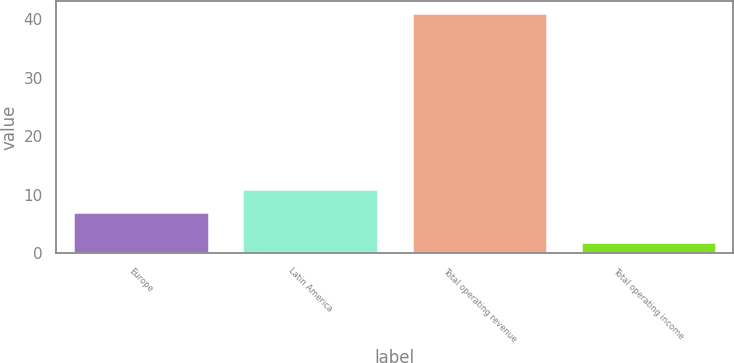<chart> <loc_0><loc_0><loc_500><loc_500><bar_chart><fcel>Europe<fcel>Latin America<fcel>Total operating revenue<fcel>Total operating income<nl><fcel>7<fcel>10.9<fcel>41<fcel>2<nl></chart> 